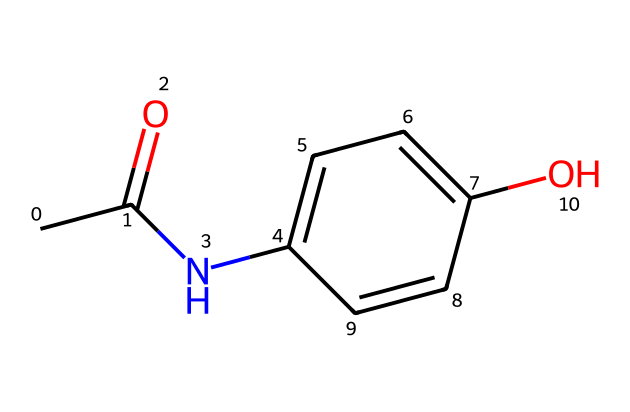What is the molecular formula of this substance? The SMILES representation can be interpreted to construct the molecular formula by analyzing the atoms present: 4 carbon (C), 5 hydrogen (H), 1 nitrogen (N), 1 oxygen (O), and another oxygen from the acetyl group, totaling C8H9NO2.
Answer: C8H9NO2 How many rings are present in the molecular structure? The provided SMILES representation indicates that there is only one ring, as observed from the number "1" indicating the start and end of the cyclic structure connected through the atoms within the ring.
Answer: 1 What functional group is present in this molecule? In the structure, an amine group (NH) is present alongside a phenolic hydroxyl group (OH) and a carbonyl group (C=O), thus indicating that an amide functional group is present.
Answer: amide What is the primary function of this molecule in medicine? Paracetamol, also known as acetaminophen, is primarily known for its analgesic (pain-relieving) and antipyretic (fever-reducing) properties, making it widely used for treating mild to moderate pain and reducing fever.
Answer: analgesic Which atom connects the aromatic ring to the carbonyl group in this molecule? In the structural representation, it can be identified that a nitrogen atom (N) connects the aromatic ring to the carbonyl group, indicating the link between the aromatic part and the amide group.
Answer: nitrogen What type of drug is this molecule classified as? Based on its structure and therapeutic use, this molecule is classified as a non-opioid analgesic which differentiates it from opioid drugs that have a different mechanism of action.
Answer: non-opioid analgesic 